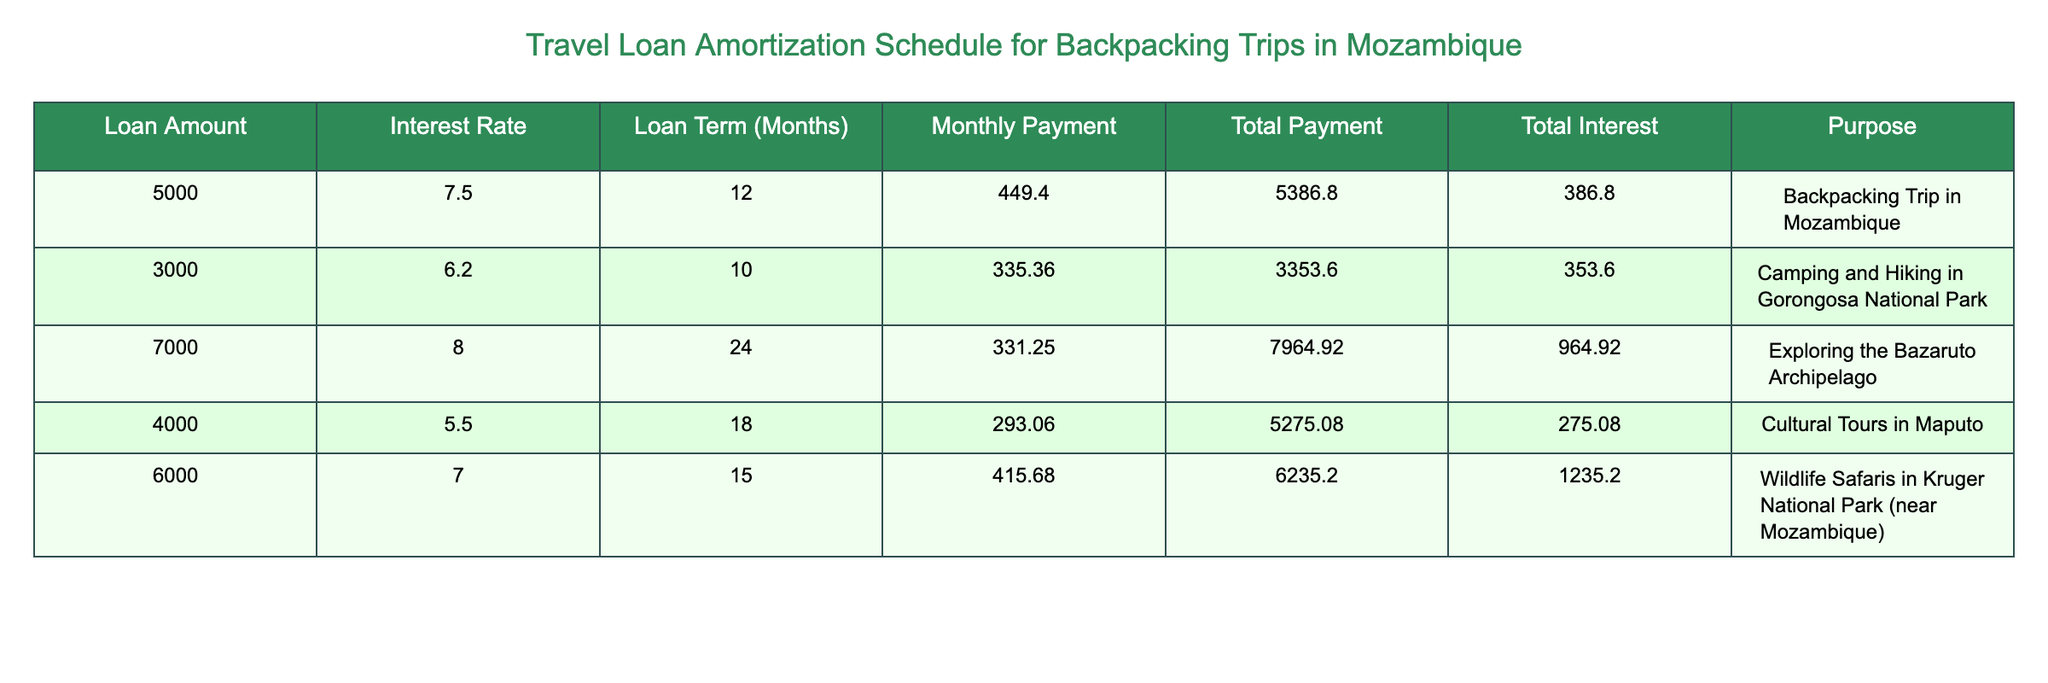What is the loan amount for the backpacking trip in Mozambique? The table indicates that the loan amount for the backpacking trip in Mozambique is 5000. This can be seen in the row corresponding to the purpose "Backpacking Trip in Mozambique."
Answer: 5000 What is the total interest paid for camping and hiking in Gorongosa National Park? According to the table, the total interest paid for camping and hiking in Gorongosa National Park is 353.60. This is found in the row where the purpose is listed as "Camping and Hiking in Gorongosa National Park."
Answer: 353.60 Which trip has the highest total payment and what is the amount? By examining the total payment amounts across all trips, the highest total payment is 7964.92, which corresponds to the trip "Exploring the Bazaruto Archipelago."
Answer: 7964.92 What is the difference in loan amount between the cultural tours in Maputo and the wildlife safaris near Mozambique? The loan amount for cultural tours in Maputo is 4000 while the loan amount for the wildlife safaris is 6000. The difference is 6000 - 4000 = 2000. Therefore, the difference in loan amount is 2000.
Answer: 2000 Is the total interest paid for the backpacking trip in Mozambique greater than for the cultural tours in Maputo? The total interest for the backpacking trip is 386.80, while for cultural tours, it is 275.08. Since 386.80 is greater than 275.08, the statement is true.
Answer: Yes What is the average monthly payment across all trips? The monthly payments for all trips are as follows: 449.40, 335.36, 331.25, 293.06, 415.68. Summing these values gives a total of 2024.75 and there are 5 trips, so the average monthly payment is 2024.75 / 5 = 404.95.
Answer: 404.95 Which trip has the lowest interest rate and what is the rate? The lowest interest rate in the table is 5.5, which corresponds to the cultural tours in Maputo. This is evident from the row that lists the cultural tours.
Answer: 5.5 What is the total payment for exploring the Bazaruto Archipelago? According to the table, the total payment for exploring the Bazaruto Archipelago is 7964.92, which is specified in the row for that purpose.
Answer: 7964.92 How many trips have a loan term greater than 15 months? Looking at the table, the trips with loan terms greater than 15 months are: "Exploring the Bazaruto Archipelago" (24 months), "Wildlife Safaris" (15 months), and none of the others exceed 15 months. Thus, 3 trips qualify.
Answer: 3 